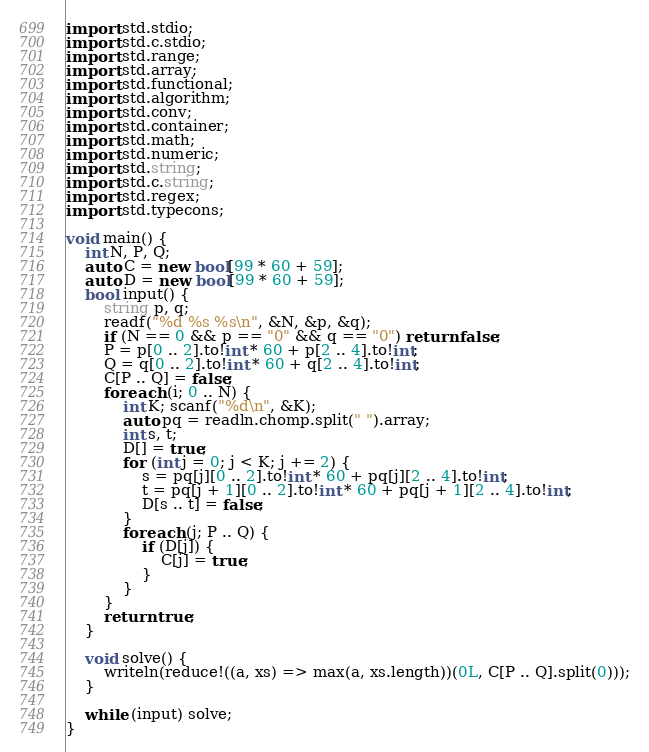<code> <loc_0><loc_0><loc_500><loc_500><_D_>import std.stdio;
import std.c.stdio;
import std.range;
import std.array;
import std.functional;
import std.algorithm;
import std.conv;
import std.container;
import std.math;
import std.numeric;
import std.string;
import std.c.string;
import std.regex;
import std.typecons;
 
void main() {
    int N, P, Q;
    auto C = new bool[99 * 60 + 59];
    auto D = new bool[99 * 60 + 59];
    bool input() {
        string p, q;
        readf("%d %s %s\n", &N, &p, &q);
        if (N == 0 && p == "0" && q == "0") return false;
        P = p[0 .. 2].to!int * 60 + p[2 .. 4].to!int;
        Q = q[0 .. 2].to!int * 60 + q[2 .. 4].to!int;
        C[P .. Q] = false;
        foreach (i; 0 .. N) {
            int K; scanf("%d\n", &K);
            auto pq = readln.chomp.split(" ").array;
            int s, t;
            D[] = true;
            for (int j = 0; j < K; j += 2) {
                s = pq[j][0 .. 2].to!int * 60 + pq[j][2 .. 4].to!int;
                t = pq[j + 1][0 .. 2].to!int * 60 + pq[j + 1][2 .. 4].to!int;
                D[s .. t] = false;
            }
            foreach (j; P .. Q) {
                if (D[j]) {
                    C[j] = true;
                }
            }
        }
        return true;
    }

    void solve() {
        writeln(reduce!((a, xs) => max(a, xs.length))(0L, C[P .. Q].split(0)));
    }
    
    while (input) solve;
}</code> 